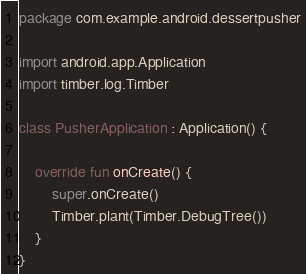<code> <loc_0><loc_0><loc_500><loc_500><_Kotlin_>
package com.example.android.dessertpusher

import android.app.Application
import timber.log.Timber

class PusherApplication : Application() {

    override fun onCreate() {
        super.onCreate()
        Timber.plant(Timber.DebugTree())
    }
}</code> 